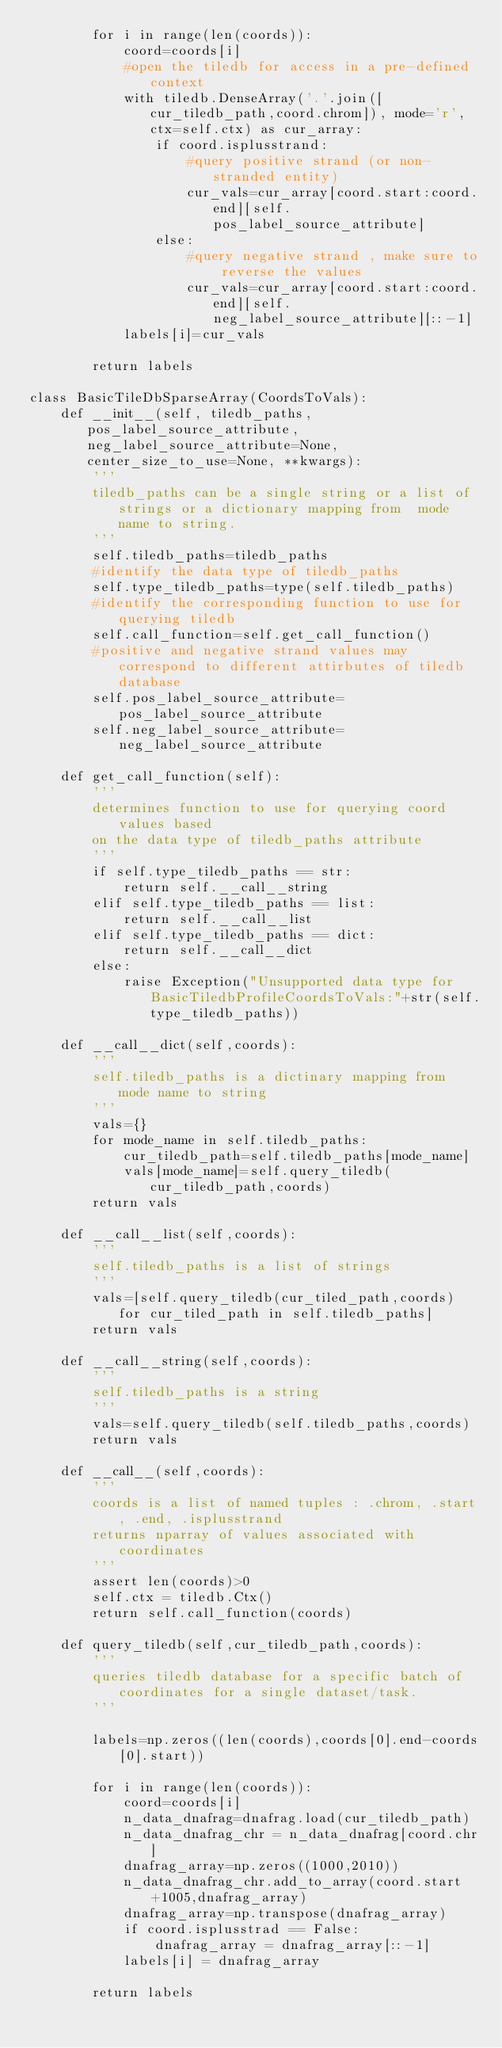<code> <loc_0><loc_0><loc_500><loc_500><_Python_>        for i in range(len(coords)):
            coord=coords[i]
            #open the tiledb for access in a pre-defined context 
            with tiledb.DenseArray('.'.join([cur_tiledb_path,coord.chrom]), mode='r',ctx=self.ctx) as cur_array:
                if coord.isplusstrand:
                    #query positive strand (or non-stranded entity)
                    cur_vals=cur_array[coord.start:coord.end][self.pos_label_source_attribute]
                else:
                    #query negative strand , make sure to reverse the values
                    cur_vals=cur_array[coord.start:coord.end][self.neg_label_source_attribute][::-1]
            labels[i]=cur_vals

        return labels

class BasicTileDbSparseArray(CoordsToVals):
    def __init__(self, tiledb_paths, pos_label_source_attribute, neg_label_source_attribute=None, center_size_to_use=None, **kwargs):
        '''
        tiledb_paths can be a single string or a list of strings or a dictionary mapping from  mode name to string. 
        '''
        self.tiledb_paths=tiledb_paths
        #identify the data type of tiledb_paths 
        self.type_tiledb_paths=type(self.tiledb_paths)
        #identify the corresponding function to use for querying tiledb 
        self.call_function=self.get_call_function()
        #positive and negative strand values may correspond to different attirbutes of tiledb database
        self.pos_label_source_attribute=pos_label_source_attribute
        self.neg_label_source_attribute=neg_label_source_attribute

    def get_call_function(self):
        '''
        determines function to use for querying coord values based 
        on the data type of tiledb_paths attribute 
        '''
        if self.type_tiledb_paths == str:
            return self.__call__string
        elif self.type_tiledb_paths == list:
            return self.__call__list
        elif self.type_tiledb_paths == dict:
            return self.__call__dict
        else:
            raise Exception("Unsupported data type for BasicTiledbProfileCoordsToVals:"+str(self.type_tiledb_paths))
                
    def __call__dict(self,coords):
        '''
        self.tiledb_paths is a dictinary mapping from mode name to string
        '''
        vals={}
        for mode_name in self.tiledb_paths:
            cur_tiledb_path=self.tiledb_paths[mode_name]
            vals[mode_name]=self.query_tiledb(cur_tiledb_path,coords)
        return vals
    
    def __call__list(self,coords):
        '''
        self.tiledb_paths is a list of strings  
        '''
        vals=[self.query_tiledb(cur_tiled_path,coords) for cur_tiled_path in self.tiledb_paths]
        return vals 
    
    def __call__string(self,coords):
        '''
        self.tiledb_paths is a string 
        '''
        vals=self.query_tiledb(self.tiledb_paths,coords)
        return vals
    
    def __call__(self,coords):
        '''
        coords is a list of named tuples : .chrom, .start, .end, .isplusstrand    
        returns nparray of values associated with coordinates
        '''
        assert len(coords)>0        
        self.ctx = tiledb.Ctx()
        return self.call_function(coords)

    def query_tiledb(self,cur_tiledb_path,coords):
        '''
        queries tiledb database for a specific batch of coordinates for a single dataset/task. 
        '''

        labels=np.zeros((len(coords),coords[0].end-coords[0].start))

        for i in range(len(coords)):
            coord=coords[i]
            n_data_dnafrag=dnafrag.load(cur_tiledb_path)
            n_data_dnafrag_chr = n_data_dnafrag[coord.chr]
            dnafrag_array=np.zeros((1000,2010))
            n_data_dnafrag_chr.add_to_array(coord.start+1005,dnafrag_array)
            dnafrag_array=np.transpose(dnafrag_array)
            if coord.isplusstrad == False:
                dnafrag_array = dnafrag_array[::-1]
            labels[i] = dnafrag_array
        
        return labels
</code> 